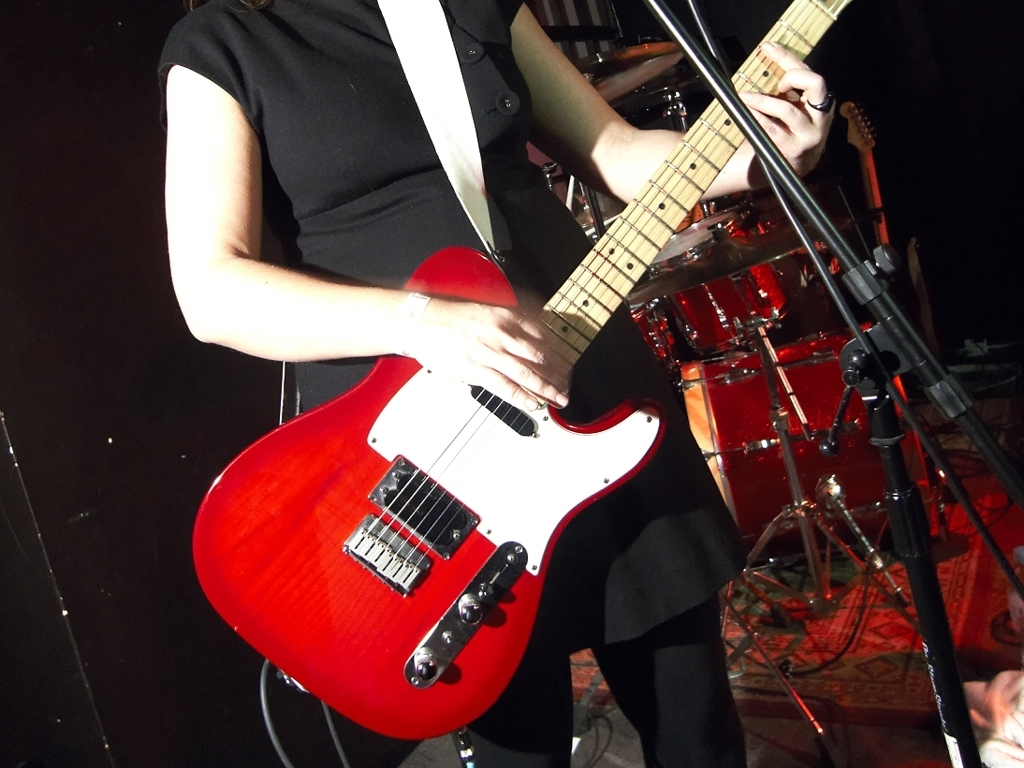What type of instrument is prominent in the image? The image prominently features a red electric guitar, which is a staple in many musical genres, notably rock and pop. 